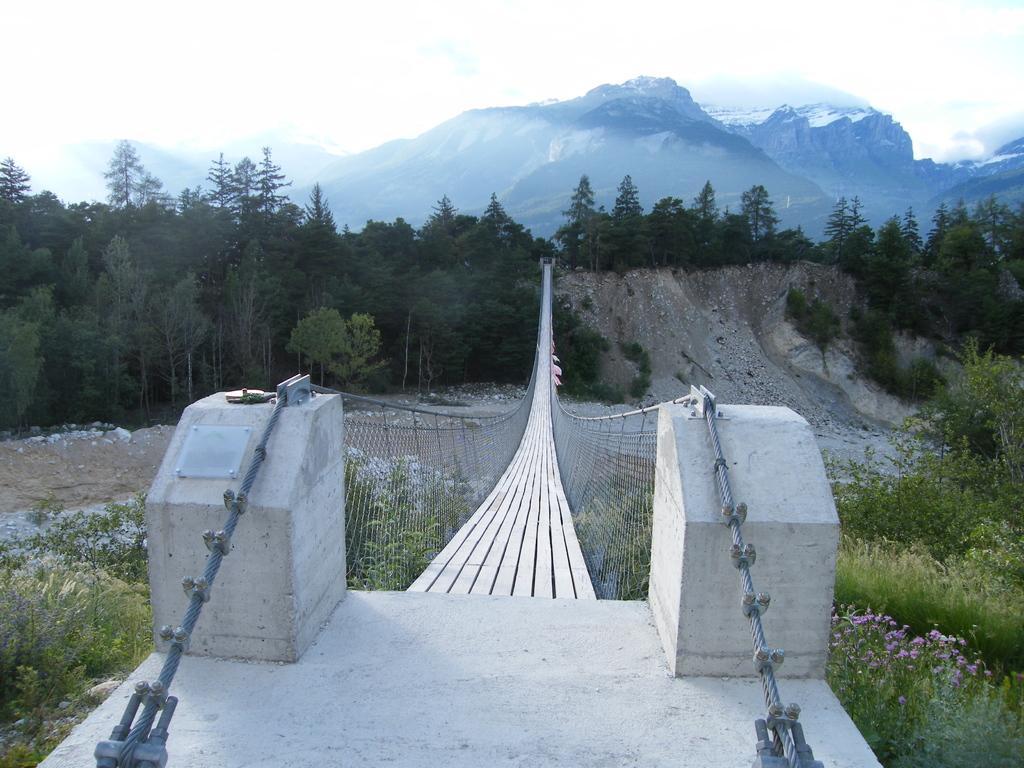Can you describe this image briefly? In this image we can see many mountains. There are many trees and plants in the image. There is a bridge in the image. There is a sky in the image. 